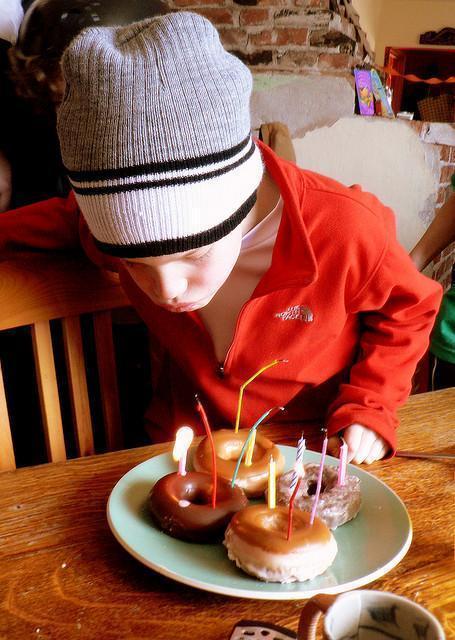What is the boy about to do?
Indicate the correct response by choosing from the four available options to answer the question.
Options: Spit, throw up, blow candle, smell. Blow candle. 